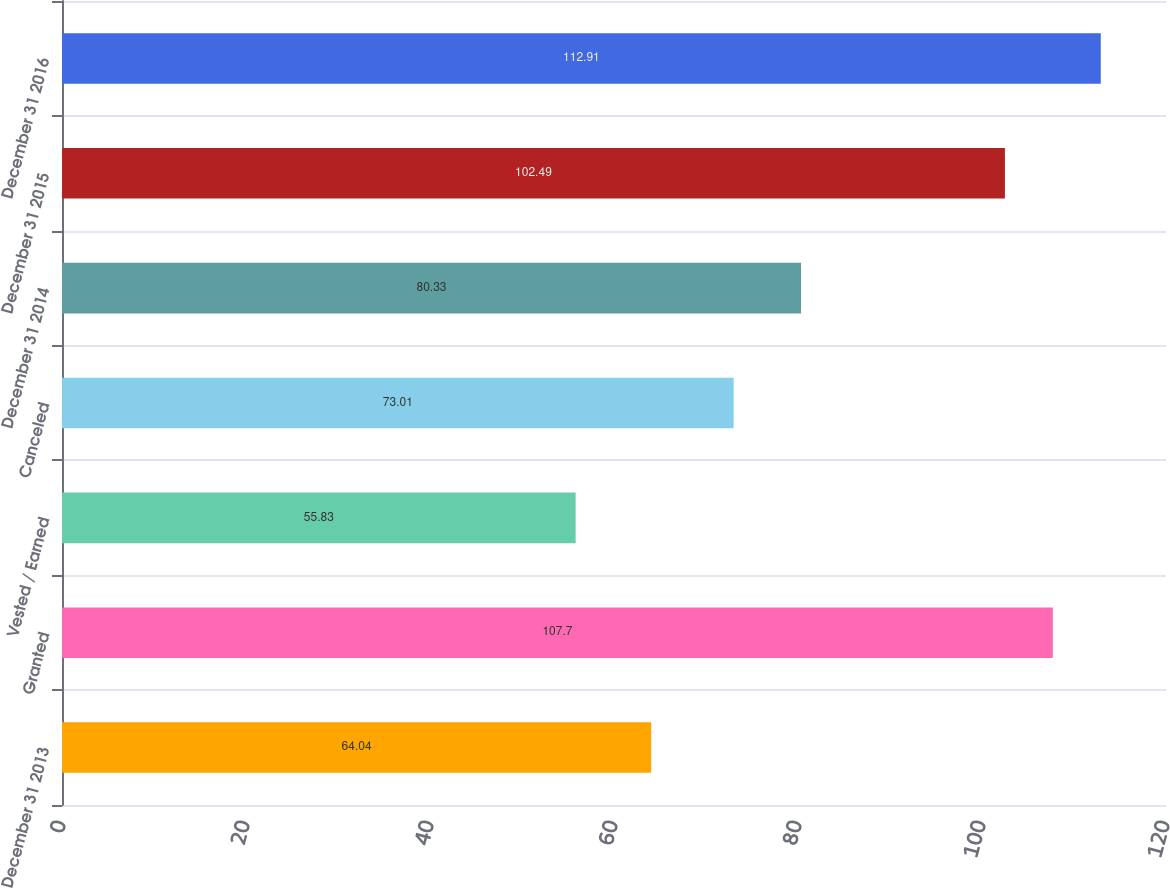Convert chart to OTSL. <chart><loc_0><loc_0><loc_500><loc_500><bar_chart><fcel>December 31 2013<fcel>Granted<fcel>Vested / Earned<fcel>Canceled<fcel>December 31 2014<fcel>December 31 2015<fcel>December 31 2016<nl><fcel>64.04<fcel>107.7<fcel>55.83<fcel>73.01<fcel>80.33<fcel>102.49<fcel>112.91<nl></chart> 